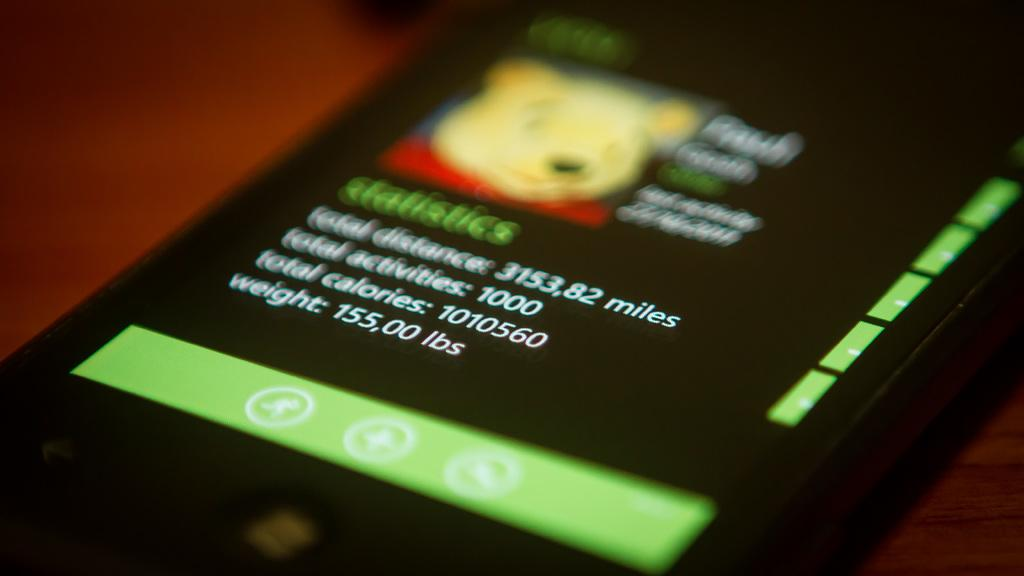<image>
Create a compact narrative representing the image presented. a blurred cell phone display shows words like Weight 155,00 lbs 